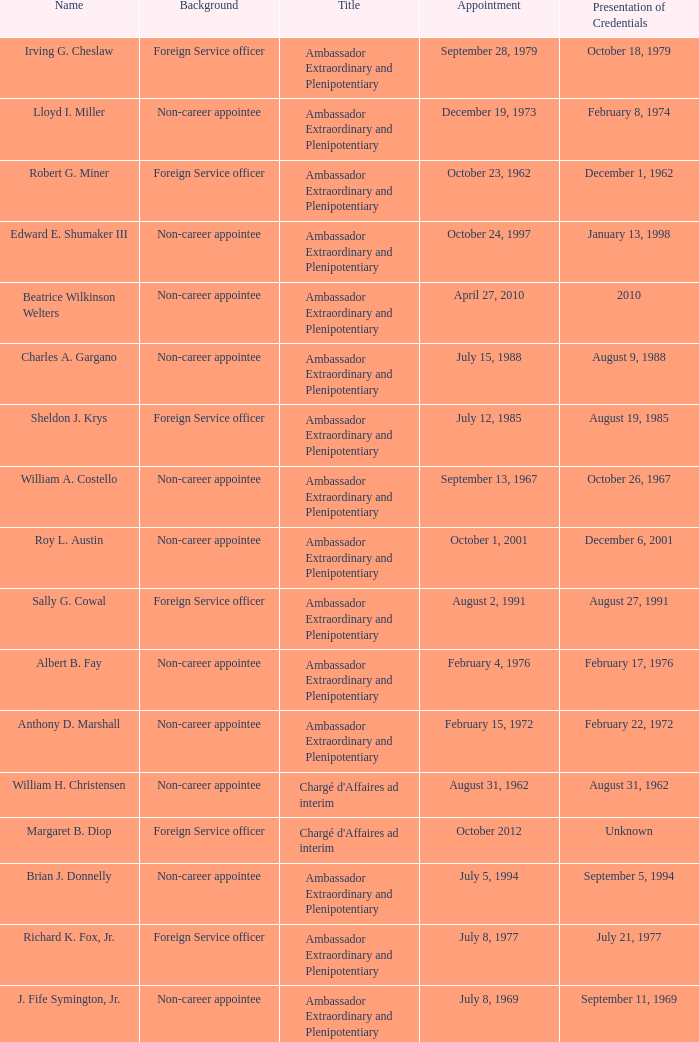Can you parse all the data within this table? {'header': ['Name', 'Background', 'Title', 'Appointment', 'Presentation of Credentials'], 'rows': [['Irving G. Cheslaw', 'Foreign Service officer', 'Ambassador Extraordinary and Plenipotentiary', 'September 28, 1979', 'October 18, 1979'], ['Lloyd I. Miller', 'Non-career appointee', 'Ambassador Extraordinary and Plenipotentiary', 'December 19, 1973', 'February 8, 1974'], ['Robert G. Miner', 'Foreign Service officer', 'Ambassador Extraordinary and Plenipotentiary', 'October 23, 1962', 'December 1, 1962'], ['Edward E. Shumaker III', 'Non-career appointee', 'Ambassador Extraordinary and Plenipotentiary', 'October 24, 1997', 'January 13, 1998'], ['Beatrice Wilkinson Welters', 'Non-career appointee', 'Ambassador Extraordinary and Plenipotentiary', 'April 27, 2010', '2010'], ['Charles A. Gargano', 'Non-career appointee', 'Ambassador Extraordinary and Plenipotentiary', 'July 15, 1988', 'August 9, 1988'], ['Sheldon J. Krys', 'Foreign Service officer', 'Ambassador Extraordinary and Plenipotentiary', 'July 12, 1985', 'August 19, 1985'], ['William A. Costello', 'Non-career appointee', 'Ambassador Extraordinary and Plenipotentiary', 'September 13, 1967', 'October 26, 1967'], ['Roy L. Austin', 'Non-career appointee', 'Ambassador Extraordinary and Plenipotentiary', 'October 1, 2001', 'December 6, 2001'], ['Sally G. Cowal', 'Foreign Service officer', 'Ambassador Extraordinary and Plenipotentiary', 'August 2, 1991', 'August 27, 1991'], ['Albert B. Fay', 'Non-career appointee', 'Ambassador Extraordinary and Plenipotentiary', 'February 4, 1976', 'February 17, 1976'], ['Anthony D. Marshall', 'Non-career appointee', 'Ambassador Extraordinary and Plenipotentiary', 'February 15, 1972', 'February 22, 1972'], ['William H. Christensen', 'Non-career appointee', "Chargé d'Affaires ad interim", 'August 31, 1962', 'August 31, 1962'], ['Margaret B. Diop', 'Foreign Service officer', "Chargé d'Affaires ad interim", 'October 2012', 'Unknown'], ['Brian J. Donnelly', 'Non-career appointee', 'Ambassador Extraordinary and Plenipotentiary', 'July 5, 1994', 'September 5, 1994'], ['Richard K. Fox, Jr.', 'Foreign Service officer', 'Ambassador Extraordinary and Plenipotentiary', 'July 8, 1977', 'July 21, 1977'], ['J. Fife Symington, Jr.', 'Non-career appointee', 'Ambassador Extraordinary and Plenipotentiary', 'July 8, 1969', 'September 11, 1969'], ['Melvin Herbert Evans', 'Non-career appointee', 'Ambassador Extraordinary and Plenipotentiary', 'December 1, 1981', 'January 1, 1982']]} What was Anthony D. Marshall's title? Ambassador Extraordinary and Plenipotentiary. 